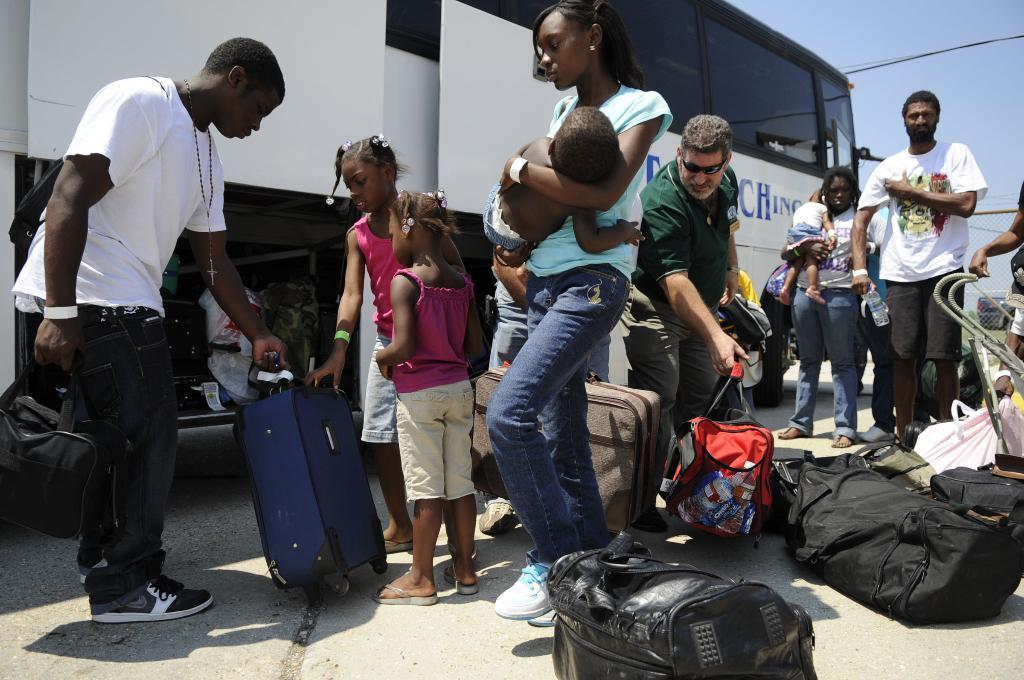Who or what is present in the image? There are people in the image. What are the people doing in the image? The people are standing in front of a bus. What objects are near the people in the image? The people have luggage on the floor. What can be seen in the background of the image? There is a sky visible in the background of the image. What type of grape is being used as a curtain in the image? There is no grape or curtain present in the image. 